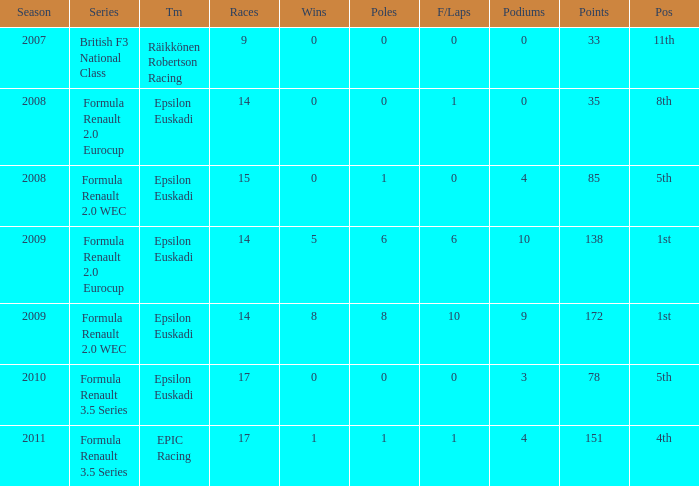How many f/laps when he finished 8th? 1.0. 